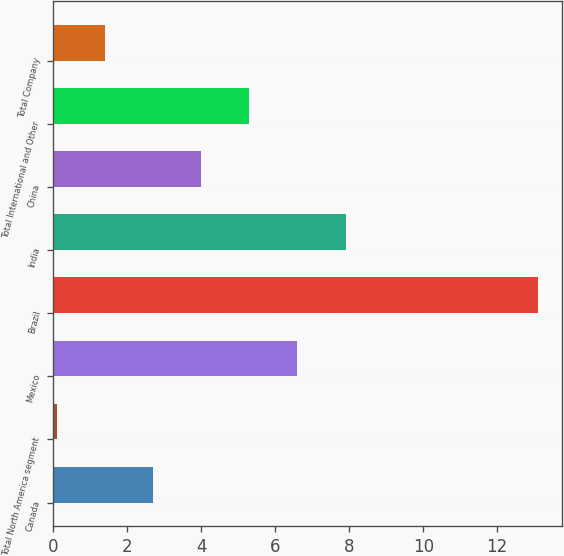<chart> <loc_0><loc_0><loc_500><loc_500><bar_chart><fcel>Canada<fcel>Total North America segment<fcel>Mexico<fcel>Brazil<fcel>India<fcel>China<fcel>Total International and Other<fcel>Total Company<nl><fcel>2.7<fcel>0.1<fcel>6.6<fcel>13.1<fcel>7.9<fcel>4<fcel>5.3<fcel>1.4<nl></chart> 